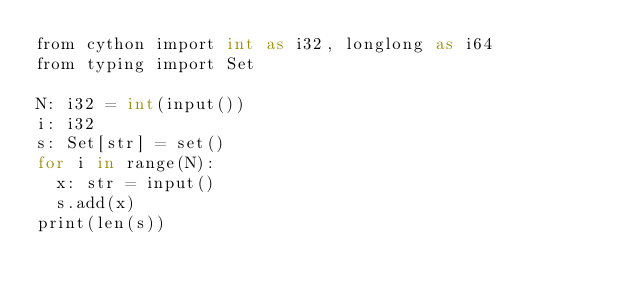Convert code to text. <code><loc_0><loc_0><loc_500><loc_500><_Cython_>from cython import int as i32, longlong as i64
from typing import Set

N: i32 = int(input())
i: i32
s: Set[str] = set()
for i in range(N):
  x: str = input()
  s.add(x)
print(len(s))
</code> 